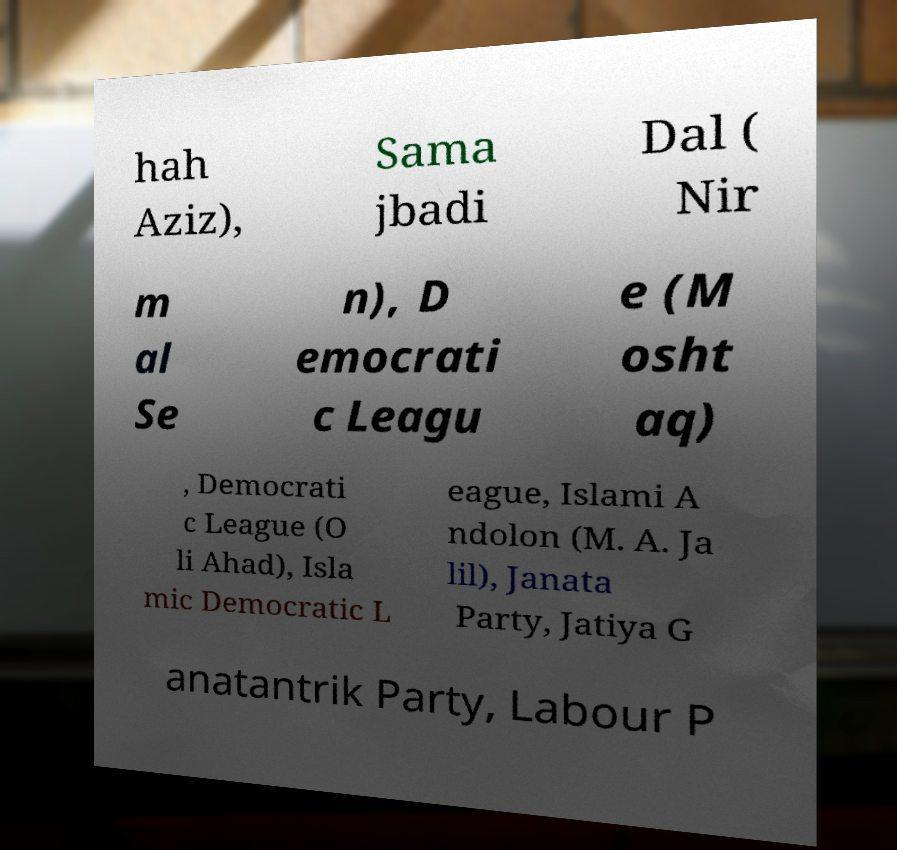What messages or text are displayed in this image? I need them in a readable, typed format. hah Aziz), Sama jbadi Dal ( Nir m al Se n), D emocrati c Leagu e (M osht aq) , Democrati c League (O li Ahad), Isla mic Democratic L eague, Islami A ndolon (M. A. Ja lil), Janata Party, Jatiya G anatantrik Party, Labour P 